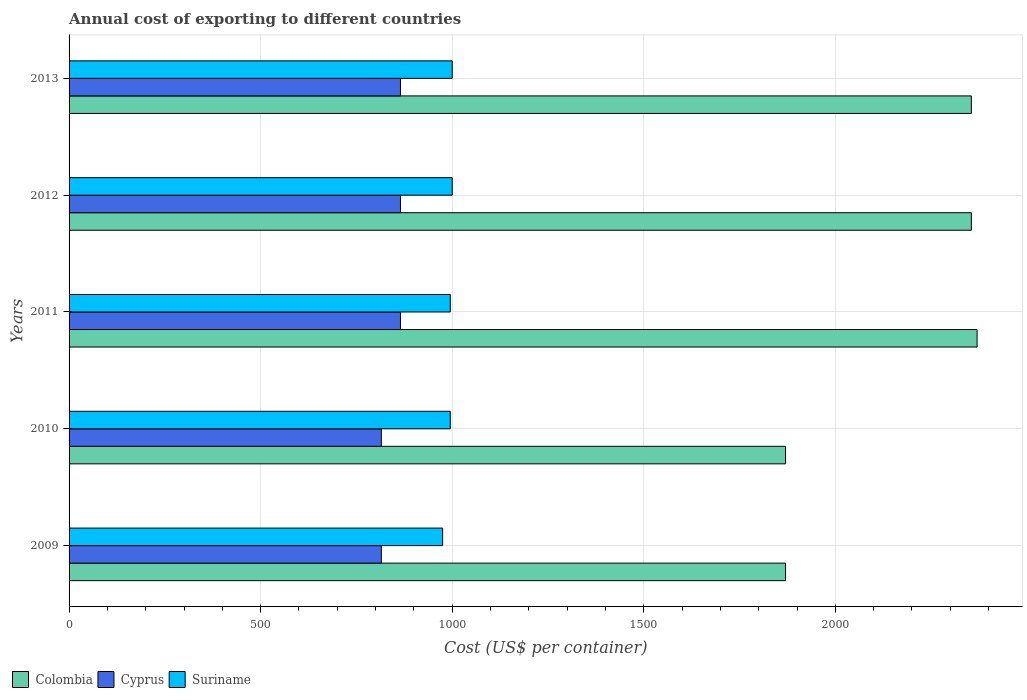How many different coloured bars are there?
Provide a succinct answer. 3. Are the number of bars per tick equal to the number of legend labels?
Your answer should be very brief. Yes. Are the number of bars on each tick of the Y-axis equal?
Your answer should be compact. Yes. How many bars are there on the 5th tick from the top?
Provide a succinct answer. 3. How many bars are there on the 3rd tick from the bottom?
Make the answer very short. 3. What is the label of the 4th group of bars from the top?
Keep it short and to the point. 2010. What is the total annual cost of exporting in Cyprus in 2010?
Give a very brief answer. 815. Across all years, what is the maximum total annual cost of exporting in Cyprus?
Give a very brief answer. 865. Across all years, what is the minimum total annual cost of exporting in Suriname?
Give a very brief answer. 975. In which year was the total annual cost of exporting in Suriname maximum?
Give a very brief answer. 2012. What is the total total annual cost of exporting in Suriname in the graph?
Keep it short and to the point. 4965. What is the difference between the total annual cost of exporting in Colombia in 2010 and the total annual cost of exporting in Suriname in 2011?
Offer a terse response. 875. What is the average total annual cost of exporting in Suriname per year?
Keep it short and to the point. 993. In the year 2013, what is the difference between the total annual cost of exporting in Suriname and total annual cost of exporting in Cyprus?
Make the answer very short. 135. What is the ratio of the total annual cost of exporting in Cyprus in 2010 to that in 2012?
Keep it short and to the point. 0.94. Is the difference between the total annual cost of exporting in Suriname in 2011 and 2013 greater than the difference between the total annual cost of exporting in Cyprus in 2011 and 2013?
Offer a very short reply. No. What does the 1st bar from the top in 2011 represents?
Your answer should be compact. Suriname. What does the 2nd bar from the bottom in 2012 represents?
Your answer should be compact. Cyprus. Is it the case that in every year, the sum of the total annual cost of exporting in Colombia and total annual cost of exporting in Cyprus is greater than the total annual cost of exporting in Suriname?
Keep it short and to the point. Yes. How are the legend labels stacked?
Keep it short and to the point. Horizontal. What is the title of the graph?
Offer a very short reply. Annual cost of exporting to different countries. What is the label or title of the X-axis?
Keep it short and to the point. Cost (US$ per container). What is the Cost (US$ per container) of Colombia in 2009?
Your answer should be very brief. 1870. What is the Cost (US$ per container) in Cyprus in 2009?
Offer a very short reply. 815. What is the Cost (US$ per container) in Suriname in 2009?
Your answer should be very brief. 975. What is the Cost (US$ per container) in Colombia in 2010?
Your response must be concise. 1870. What is the Cost (US$ per container) of Cyprus in 2010?
Your response must be concise. 815. What is the Cost (US$ per container) of Suriname in 2010?
Provide a succinct answer. 995. What is the Cost (US$ per container) in Colombia in 2011?
Your response must be concise. 2370. What is the Cost (US$ per container) in Cyprus in 2011?
Give a very brief answer. 865. What is the Cost (US$ per container) in Suriname in 2011?
Make the answer very short. 995. What is the Cost (US$ per container) of Colombia in 2012?
Keep it short and to the point. 2355. What is the Cost (US$ per container) of Cyprus in 2012?
Your answer should be very brief. 865. What is the Cost (US$ per container) in Colombia in 2013?
Provide a short and direct response. 2355. What is the Cost (US$ per container) of Cyprus in 2013?
Make the answer very short. 865. Across all years, what is the maximum Cost (US$ per container) of Colombia?
Make the answer very short. 2370. Across all years, what is the maximum Cost (US$ per container) of Cyprus?
Your response must be concise. 865. Across all years, what is the minimum Cost (US$ per container) of Colombia?
Keep it short and to the point. 1870. Across all years, what is the minimum Cost (US$ per container) of Cyprus?
Give a very brief answer. 815. Across all years, what is the minimum Cost (US$ per container) in Suriname?
Offer a terse response. 975. What is the total Cost (US$ per container) of Colombia in the graph?
Your answer should be compact. 1.08e+04. What is the total Cost (US$ per container) of Cyprus in the graph?
Offer a very short reply. 4225. What is the total Cost (US$ per container) of Suriname in the graph?
Ensure brevity in your answer.  4965. What is the difference between the Cost (US$ per container) of Colombia in 2009 and that in 2010?
Your answer should be compact. 0. What is the difference between the Cost (US$ per container) in Cyprus in 2009 and that in 2010?
Your answer should be very brief. 0. What is the difference between the Cost (US$ per container) of Colombia in 2009 and that in 2011?
Offer a terse response. -500. What is the difference between the Cost (US$ per container) of Suriname in 2009 and that in 2011?
Provide a succinct answer. -20. What is the difference between the Cost (US$ per container) of Colombia in 2009 and that in 2012?
Provide a short and direct response. -485. What is the difference between the Cost (US$ per container) of Suriname in 2009 and that in 2012?
Give a very brief answer. -25. What is the difference between the Cost (US$ per container) of Colombia in 2009 and that in 2013?
Provide a short and direct response. -485. What is the difference between the Cost (US$ per container) of Suriname in 2009 and that in 2013?
Your answer should be compact. -25. What is the difference between the Cost (US$ per container) of Colombia in 2010 and that in 2011?
Offer a terse response. -500. What is the difference between the Cost (US$ per container) of Cyprus in 2010 and that in 2011?
Your answer should be compact. -50. What is the difference between the Cost (US$ per container) of Suriname in 2010 and that in 2011?
Offer a terse response. 0. What is the difference between the Cost (US$ per container) of Colombia in 2010 and that in 2012?
Make the answer very short. -485. What is the difference between the Cost (US$ per container) of Suriname in 2010 and that in 2012?
Your answer should be very brief. -5. What is the difference between the Cost (US$ per container) in Colombia in 2010 and that in 2013?
Provide a succinct answer. -485. What is the difference between the Cost (US$ per container) in Cyprus in 2010 and that in 2013?
Your response must be concise. -50. What is the difference between the Cost (US$ per container) in Suriname in 2011 and that in 2012?
Provide a succinct answer. -5. What is the difference between the Cost (US$ per container) in Cyprus in 2011 and that in 2013?
Keep it short and to the point. 0. What is the difference between the Cost (US$ per container) of Suriname in 2011 and that in 2013?
Your answer should be very brief. -5. What is the difference between the Cost (US$ per container) of Cyprus in 2012 and that in 2013?
Your answer should be compact. 0. What is the difference between the Cost (US$ per container) of Colombia in 2009 and the Cost (US$ per container) of Cyprus in 2010?
Provide a succinct answer. 1055. What is the difference between the Cost (US$ per container) in Colombia in 2009 and the Cost (US$ per container) in Suriname in 2010?
Offer a terse response. 875. What is the difference between the Cost (US$ per container) of Cyprus in 2009 and the Cost (US$ per container) of Suriname in 2010?
Your answer should be compact. -180. What is the difference between the Cost (US$ per container) in Colombia in 2009 and the Cost (US$ per container) in Cyprus in 2011?
Offer a terse response. 1005. What is the difference between the Cost (US$ per container) in Colombia in 2009 and the Cost (US$ per container) in Suriname in 2011?
Give a very brief answer. 875. What is the difference between the Cost (US$ per container) of Cyprus in 2009 and the Cost (US$ per container) of Suriname in 2011?
Make the answer very short. -180. What is the difference between the Cost (US$ per container) in Colombia in 2009 and the Cost (US$ per container) in Cyprus in 2012?
Give a very brief answer. 1005. What is the difference between the Cost (US$ per container) of Colombia in 2009 and the Cost (US$ per container) of Suriname in 2012?
Offer a very short reply. 870. What is the difference between the Cost (US$ per container) of Cyprus in 2009 and the Cost (US$ per container) of Suriname in 2012?
Your answer should be very brief. -185. What is the difference between the Cost (US$ per container) of Colombia in 2009 and the Cost (US$ per container) of Cyprus in 2013?
Provide a short and direct response. 1005. What is the difference between the Cost (US$ per container) of Colombia in 2009 and the Cost (US$ per container) of Suriname in 2013?
Your response must be concise. 870. What is the difference between the Cost (US$ per container) of Cyprus in 2009 and the Cost (US$ per container) of Suriname in 2013?
Provide a short and direct response. -185. What is the difference between the Cost (US$ per container) of Colombia in 2010 and the Cost (US$ per container) of Cyprus in 2011?
Provide a short and direct response. 1005. What is the difference between the Cost (US$ per container) of Colombia in 2010 and the Cost (US$ per container) of Suriname in 2011?
Provide a short and direct response. 875. What is the difference between the Cost (US$ per container) in Cyprus in 2010 and the Cost (US$ per container) in Suriname in 2011?
Offer a very short reply. -180. What is the difference between the Cost (US$ per container) in Colombia in 2010 and the Cost (US$ per container) in Cyprus in 2012?
Your response must be concise. 1005. What is the difference between the Cost (US$ per container) of Colombia in 2010 and the Cost (US$ per container) of Suriname in 2012?
Ensure brevity in your answer.  870. What is the difference between the Cost (US$ per container) in Cyprus in 2010 and the Cost (US$ per container) in Suriname in 2012?
Provide a succinct answer. -185. What is the difference between the Cost (US$ per container) in Colombia in 2010 and the Cost (US$ per container) in Cyprus in 2013?
Your answer should be compact. 1005. What is the difference between the Cost (US$ per container) of Colombia in 2010 and the Cost (US$ per container) of Suriname in 2013?
Keep it short and to the point. 870. What is the difference between the Cost (US$ per container) of Cyprus in 2010 and the Cost (US$ per container) of Suriname in 2013?
Offer a very short reply. -185. What is the difference between the Cost (US$ per container) in Colombia in 2011 and the Cost (US$ per container) in Cyprus in 2012?
Provide a succinct answer. 1505. What is the difference between the Cost (US$ per container) of Colombia in 2011 and the Cost (US$ per container) of Suriname in 2012?
Keep it short and to the point. 1370. What is the difference between the Cost (US$ per container) in Cyprus in 2011 and the Cost (US$ per container) in Suriname in 2012?
Offer a terse response. -135. What is the difference between the Cost (US$ per container) of Colombia in 2011 and the Cost (US$ per container) of Cyprus in 2013?
Offer a terse response. 1505. What is the difference between the Cost (US$ per container) in Colombia in 2011 and the Cost (US$ per container) in Suriname in 2013?
Give a very brief answer. 1370. What is the difference between the Cost (US$ per container) of Cyprus in 2011 and the Cost (US$ per container) of Suriname in 2013?
Offer a terse response. -135. What is the difference between the Cost (US$ per container) in Colombia in 2012 and the Cost (US$ per container) in Cyprus in 2013?
Keep it short and to the point. 1490. What is the difference between the Cost (US$ per container) of Colombia in 2012 and the Cost (US$ per container) of Suriname in 2013?
Your response must be concise. 1355. What is the difference between the Cost (US$ per container) in Cyprus in 2012 and the Cost (US$ per container) in Suriname in 2013?
Give a very brief answer. -135. What is the average Cost (US$ per container) of Colombia per year?
Offer a terse response. 2164. What is the average Cost (US$ per container) in Cyprus per year?
Provide a succinct answer. 845. What is the average Cost (US$ per container) in Suriname per year?
Ensure brevity in your answer.  993. In the year 2009, what is the difference between the Cost (US$ per container) in Colombia and Cost (US$ per container) in Cyprus?
Provide a short and direct response. 1055. In the year 2009, what is the difference between the Cost (US$ per container) in Colombia and Cost (US$ per container) in Suriname?
Keep it short and to the point. 895. In the year 2009, what is the difference between the Cost (US$ per container) of Cyprus and Cost (US$ per container) of Suriname?
Make the answer very short. -160. In the year 2010, what is the difference between the Cost (US$ per container) of Colombia and Cost (US$ per container) of Cyprus?
Make the answer very short. 1055. In the year 2010, what is the difference between the Cost (US$ per container) in Colombia and Cost (US$ per container) in Suriname?
Offer a terse response. 875. In the year 2010, what is the difference between the Cost (US$ per container) of Cyprus and Cost (US$ per container) of Suriname?
Make the answer very short. -180. In the year 2011, what is the difference between the Cost (US$ per container) in Colombia and Cost (US$ per container) in Cyprus?
Keep it short and to the point. 1505. In the year 2011, what is the difference between the Cost (US$ per container) in Colombia and Cost (US$ per container) in Suriname?
Your answer should be very brief. 1375. In the year 2011, what is the difference between the Cost (US$ per container) in Cyprus and Cost (US$ per container) in Suriname?
Your response must be concise. -130. In the year 2012, what is the difference between the Cost (US$ per container) in Colombia and Cost (US$ per container) in Cyprus?
Provide a succinct answer. 1490. In the year 2012, what is the difference between the Cost (US$ per container) of Colombia and Cost (US$ per container) of Suriname?
Make the answer very short. 1355. In the year 2012, what is the difference between the Cost (US$ per container) of Cyprus and Cost (US$ per container) of Suriname?
Make the answer very short. -135. In the year 2013, what is the difference between the Cost (US$ per container) of Colombia and Cost (US$ per container) of Cyprus?
Give a very brief answer. 1490. In the year 2013, what is the difference between the Cost (US$ per container) of Colombia and Cost (US$ per container) of Suriname?
Your answer should be compact. 1355. In the year 2013, what is the difference between the Cost (US$ per container) of Cyprus and Cost (US$ per container) of Suriname?
Offer a terse response. -135. What is the ratio of the Cost (US$ per container) in Colombia in 2009 to that in 2010?
Give a very brief answer. 1. What is the ratio of the Cost (US$ per container) of Suriname in 2009 to that in 2010?
Offer a terse response. 0.98. What is the ratio of the Cost (US$ per container) of Colombia in 2009 to that in 2011?
Your answer should be very brief. 0.79. What is the ratio of the Cost (US$ per container) in Cyprus in 2009 to that in 2011?
Your response must be concise. 0.94. What is the ratio of the Cost (US$ per container) of Suriname in 2009 to that in 2011?
Provide a short and direct response. 0.98. What is the ratio of the Cost (US$ per container) of Colombia in 2009 to that in 2012?
Provide a short and direct response. 0.79. What is the ratio of the Cost (US$ per container) in Cyprus in 2009 to that in 2012?
Your answer should be very brief. 0.94. What is the ratio of the Cost (US$ per container) in Suriname in 2009 to that in 2012?
Keep it short and to the point. 0.97. What is the ratio of the Cost (US$ per container) of Colombia in 2009 to that in 2013?
Ensure brevity in your answer.  0.79. What is the ratio of the Cost (US$ per container) in Cyprus in 2009 to that in 2013?
Your response must be concise. 0.94. What is the ratio of the Cost (US$ per container) in Suriname in 2009 to that in 2013?
Your response must be concise. 0.97. What is the ratio of the Cost (US$ per container) of Colombia in 2010 to that in 2011?
Your answer should be very brief. 0.79. What is the ratio of the Cost (US$ per container) in Cyprus in 2010 to that in 2011?
Offer a terse response. 0.94. What is the ratio of the Cost (US$ per container) of Suriname in 2010 to that in 2011?
Provide a succinct answer. 1. What is the ratio of the Cost (US$ per container) in Colombia in 2010 to that in 2012?
Give a very brief answer. 0.79. What is the ratio of the Cost (US$ per container) of Cyprus in 2010 to that in 2012?
Offer a terse response. 0.94. What is the ratio of the Cost (US$ per container) in Suriname in 2010 to that in 2012?
Provide a succinct answer. 0.99. What is the ratio of the Cost (US$ per container) of Colombia in 2010 to that in 2013?
Make the answer very short. 0.79. What is the ratio of the Cost (US$ per container) of Cyprus in 2010 to that in 2013?
Your answer should be very brief. 0.94. What is the ratio of the Cost (US$ per container) in Colombia in 2011 to that in 2012?
Your answer should be compact. 1.01. What is the ratio of the Cost (US$ per container) of Suriname in 2011 to that in 2012?
Your answer should be compact. 0.99. What is the ratio of the Cost (US$ per container) of Colombia in 2011 to that in 2013?
Offer a terse response. 1.01. What is the ratio of the Cost (US$ per container) in Cyprus in 2011 to that in 2013?
Ensure brevity in your answer.  1. What is the ratio of the Cost (US$ per container) in Suriname in 2011 to that in 2013?
Give a very brief answer. 0.99. What is the ratio of the Cost (US$ per container) of Colombia in 2012 to that in 2013?
Offer a terse response. 1. What is the ratio of the Cost (US$ per container) of Cyprus in 2012 to that in 2013?
Make the answer very short. 1. What is the difference between the highest and the second highest Cost (US$ per container) in Colombia?
Offer a very short reply. 15. What is the difference between the highest and the lowest Cost (US$ per container) in Colombia?
Offer a terse response. 500. What is the difference between the highest and the lowest Cost (US$ per container) in Cyprus?
Your answer should be very brief. 50. What is the difference between the highest and the lowest Cost (US$ per container) of Suriname?
Your answer should be compact. 25. 